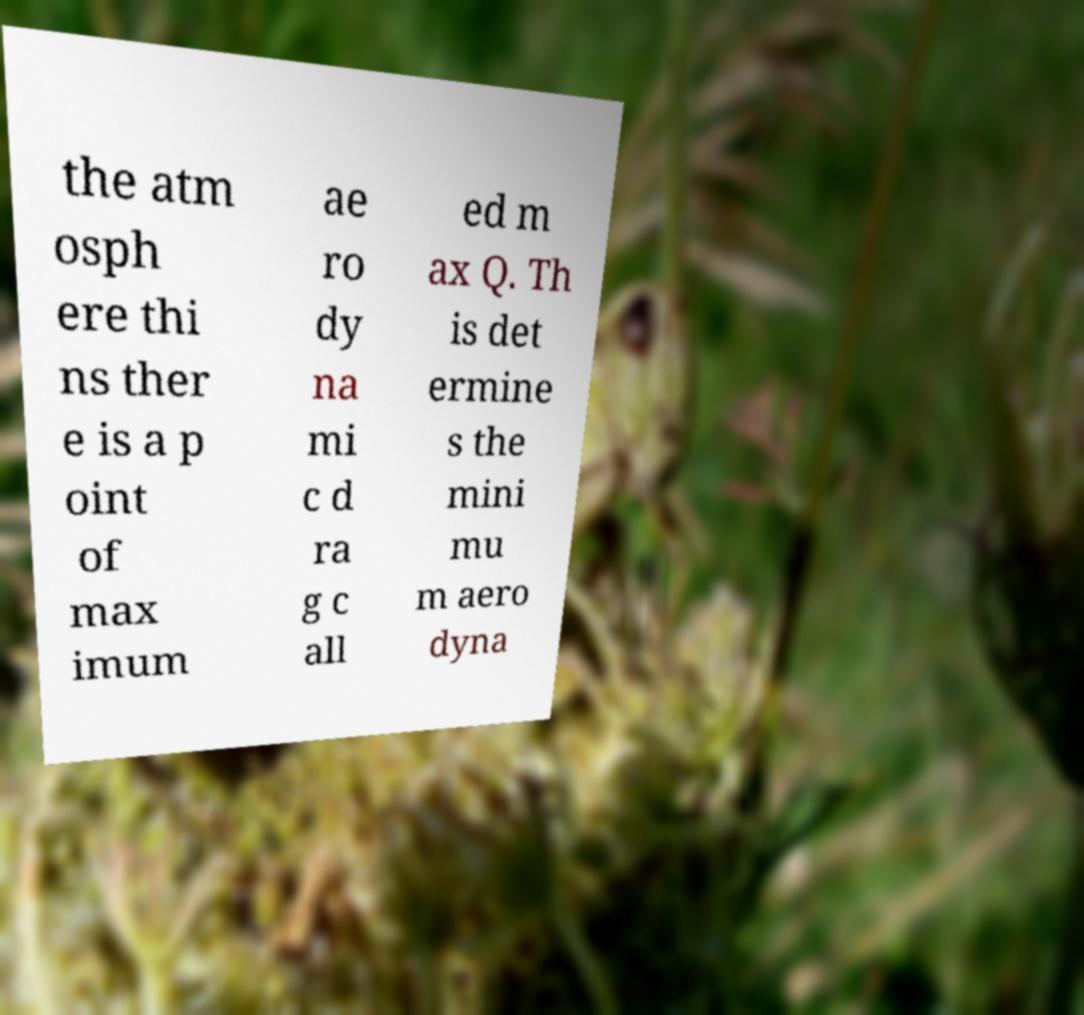There's text embedded in this image that I need extracted. Can you transcribe it verbatim? the atm osph ere thi ns ther e is a p oint of max imum ae ro dy na mi c d ra g c all ed m ax Q. Th is det ermine s the mini mu m aero dyna 